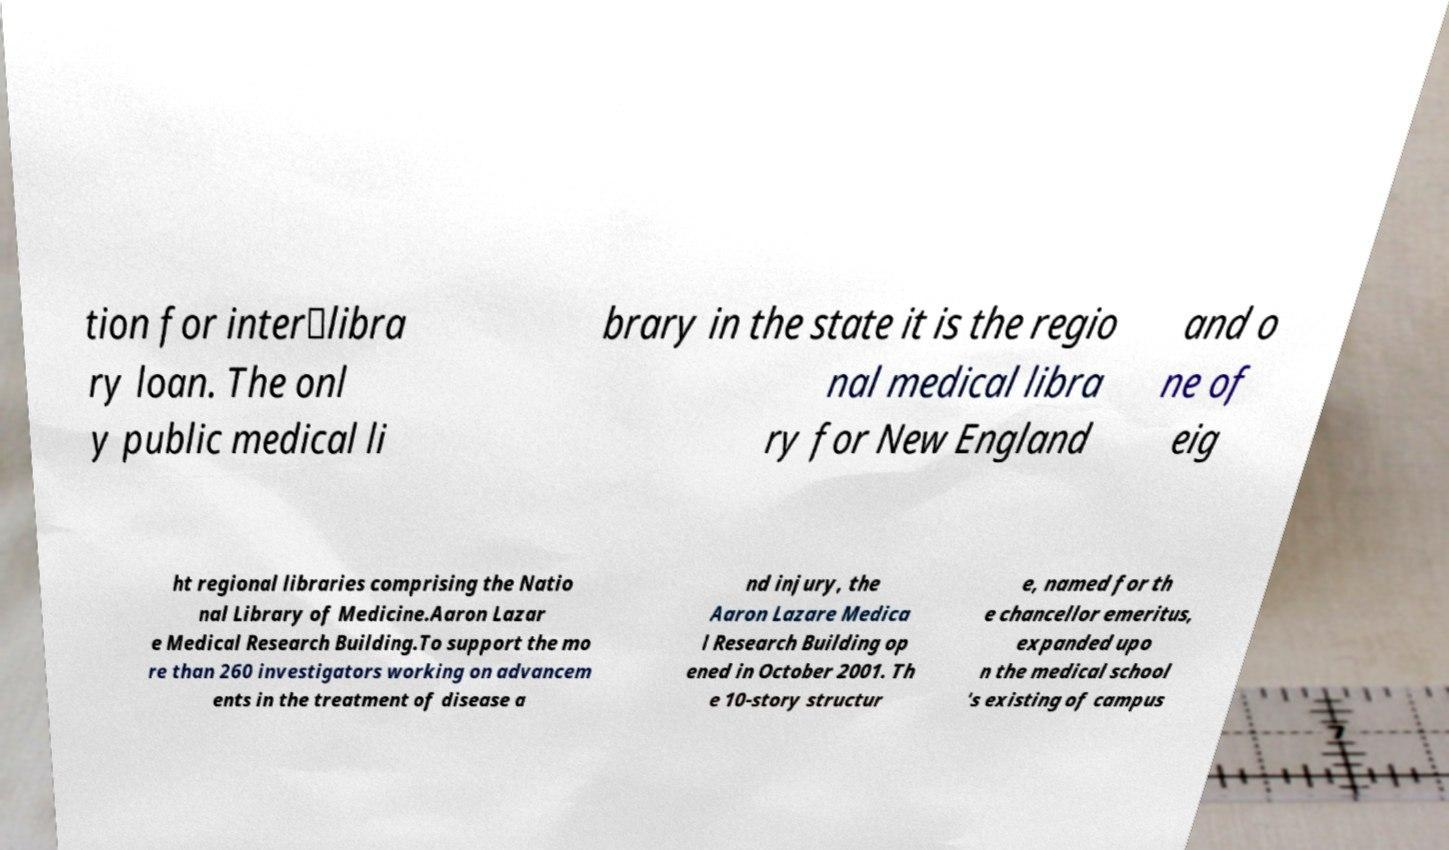Please read and relay the text visible in this image. What does it say? tion for inter‑libra ry loan. The onl y public medical li brary in the state it is the regio nal medical libra ry for New England and o ne of eig ht regional libraries comprising the Natio nal Library of Medicine.Aaron Lazar e Medical Research Building.To support the mo re than 260 investigators working on advancem ents in the treatment of disease a nd injury, the Aaron Lazare Medica l Research Building op ened in October 2001. Th e 10-story structur e, named for th e chancellor emeritus, expanded upo n the medical school 's existing of campus 